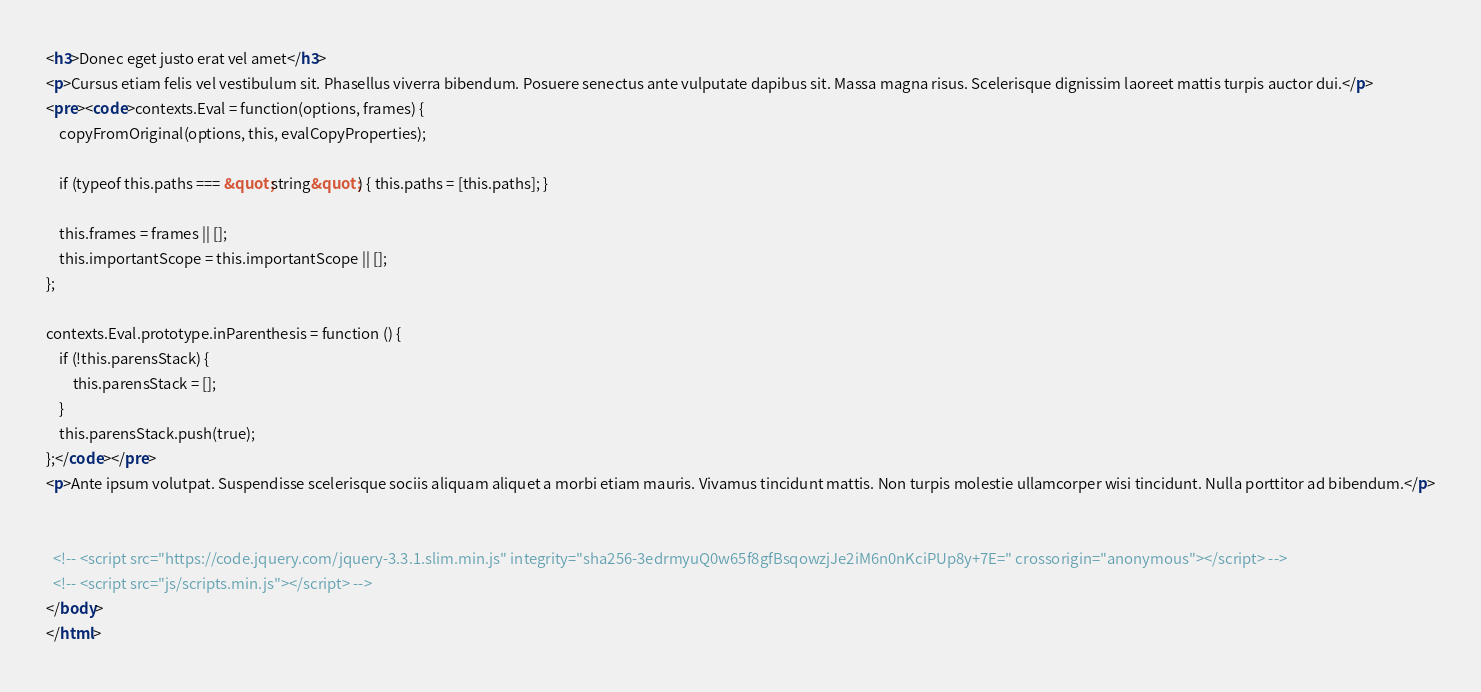Convert code to text. <code><loc_0><loc_0><loc_500><loc_500><_HTML_><h3>Donec eget justo erat vel amet</h3>
<p>Cursus etiam felis vel vestibulum sit. Phasellus viverra bibendum. Posuere senectus ante vulputate dapibus sit. Massa magna risus. Scelerisque dignissim laoreet mattis turpis auctor dui.</p>
<pre><code>contexts.Eval = function(options, frames) {
    copyFromOriginal(options, this, evalCopyProperties);

    if (typeof this.paths === &quot;string&quot;) { this.paths = [this.paths]; }

    this.frames = frames || [];
    this.importantScope = this.importantScope || [];
};

contexts.Eval.prototype.inParenthesis = function () {
    if (!this.parensStack) {
        this.parensStack = [];
    }
    this.parensStack.push(true);
};</code></pre>
<p>Ante ipsum volutpat. Suspendisse scelerisque sociis aliquam aliquet a morbi etiam mauris. Vivamus tincidunt mattis. Non turpis molestie ullamcorper wisi tincidunt. Nulla porttitor ad bibendum.</p>


  <!-- <script src="https://code.jquery.com/jquery-3.3.1.slim.min.js" integrity="sha256-3edrmyuQ0w65f8gfBsqowzjJe2iM6n0nKciPUp8y+7E=" crossorigin="anonymous"></script> -->
  <!-- <script src="js/scripts.min.js"></script> -->
</body>
</html>
</code> 